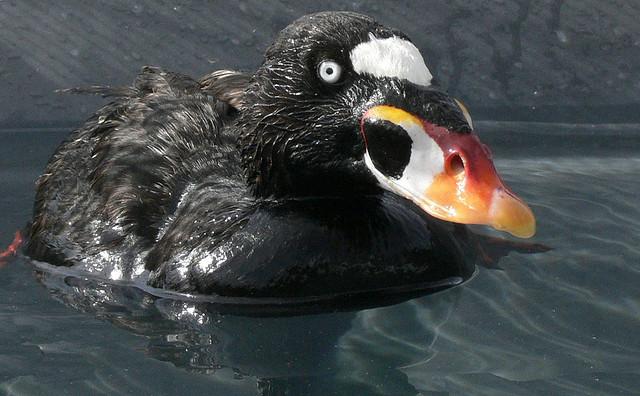Is the area surrounding the eyeball and the beak the same color?
Give a very brief answer. No. Is this a mutant duck?
Give a very brief answer. No. What type of duck is this?
Write a very short answer. I don't know. Why is this bird feather black?
Give a very brief answer. That is way bird is made. Is this bird some type of duck?
Quick response, please. Yes. 